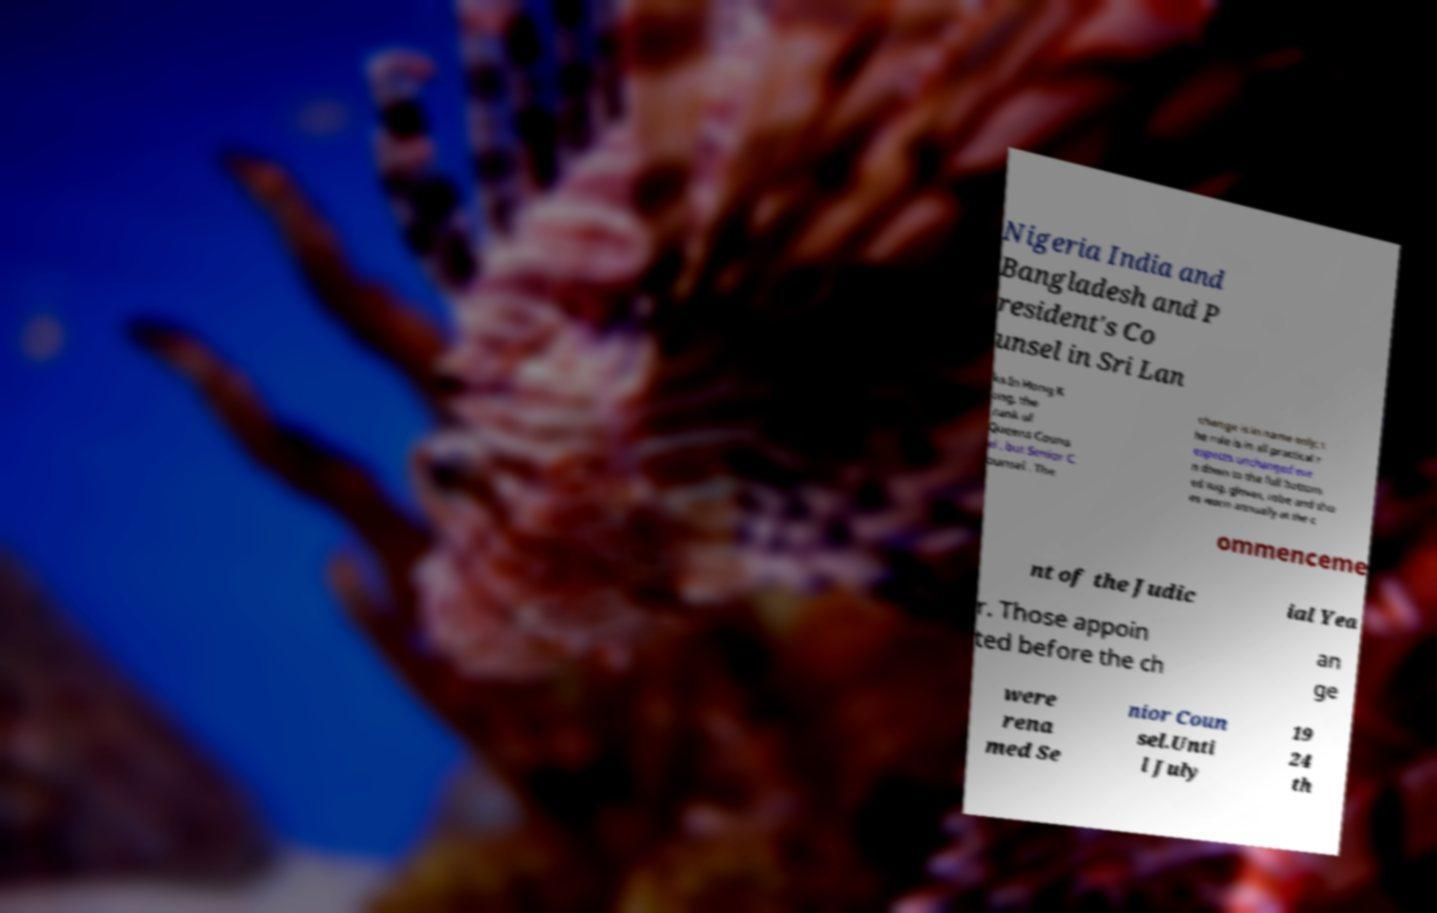Can you accurately transcribe the text from the provided image for me? Nigeria India and Bangladesh and P resident's Co unsel in Sri Lan ka.In Hong K ong, the rank of Queens Couns el , but Senior C ounsel . The change is in name only; t he role is in all practical r espects unchanged eve n down to the full bottom ed wig, gloves, robe and sho es worn annually at the c ommenceme nt of the Judic ial Yea r. Those appoin ted before the ch an ge were rena med Se nior Coun sel.Unti l July 19 24 th 